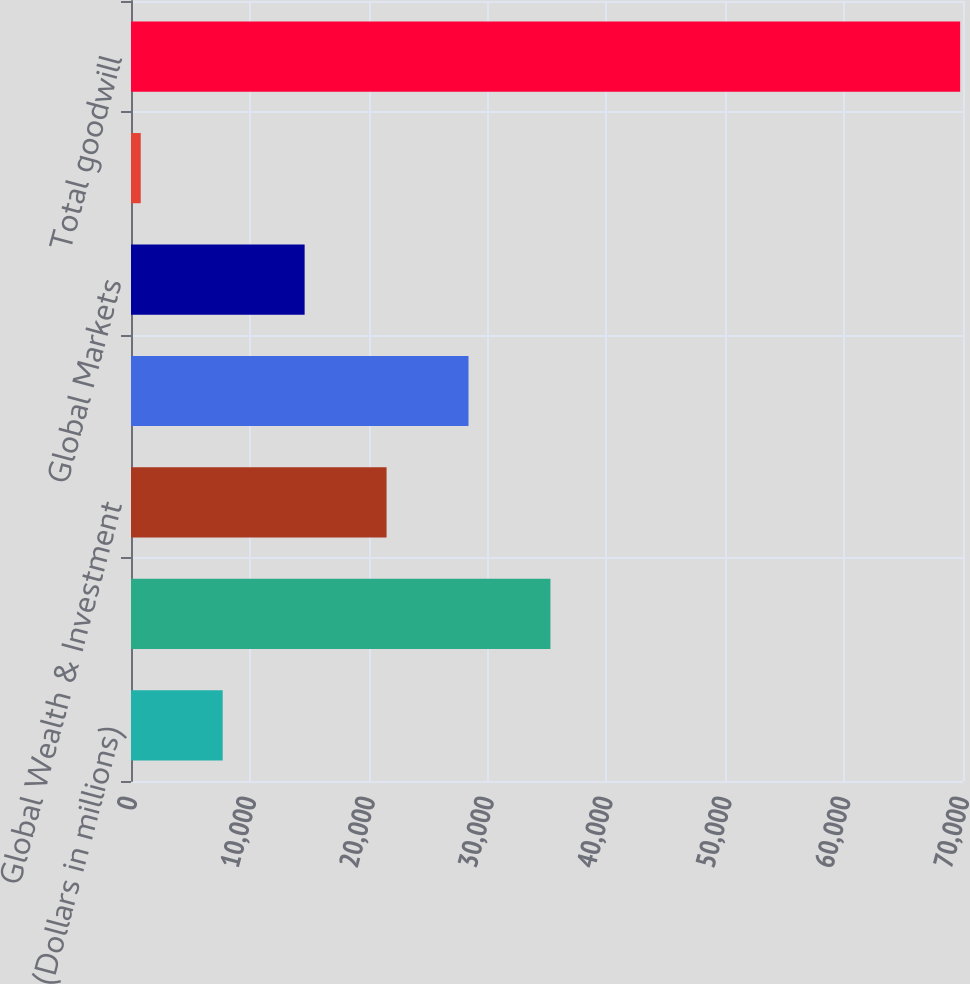Convert chart to OTSL. <chart><loc_0><loc_0><loc_500><loc_500><bar_chart><fcel>(Dollars in millions)<fcel>Consumer Banking<fcel>Global Wealth & Investment<fcel>Global Banking<fcel>Global Markets<fcel>All Other<fcel>Total goodwill<nl><fcel>7714.1<fcel>35290.5<fcel>21502.3<fcel>28396.4<fcel>14608.2<fcel>820<fcel>69761<nl></chart> 